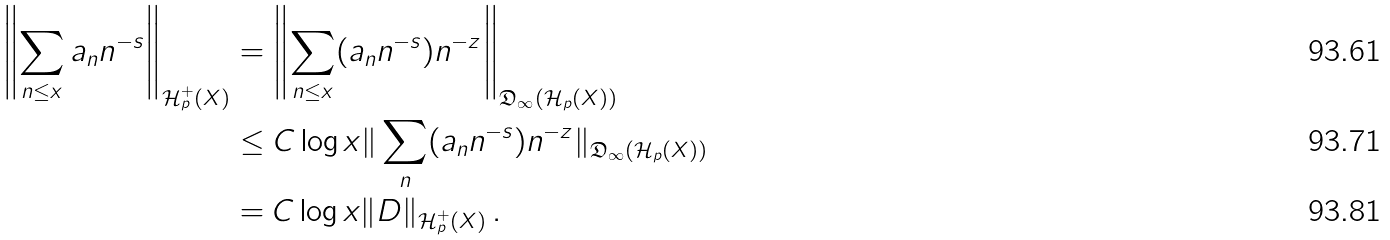Convert formula to latex. <formula><loc_0><loc_0><loc_500><loc_500>\left \| \sum _ { n \leq x } { a _ { n } n ^ { - s } } \right \| _ { \mathcal { H } ^ { + } _ { p } ( X ) } & = \left \| \sum _ { n \leq x } ( a _ { n } n ^ { - s } ) n ^ { - z } \right \| _ { \mathfrak { D } _ { \infty } ( \mathcal { H } _ { p } ( X ) ) } \\ & \leq C \log { x } \| \sum _ { n } ( a _ { n } n ^ { - s } ) n ^ { - z } \| _ { \mathfrak { D } _ { \infty } ( \mathcal { H } _ { p } ( X ) ) } \\ & = C \log { x } \| D \| _ { \mathcal { H } ^ { + } _ { p } ( X ) } \, .</formula> 